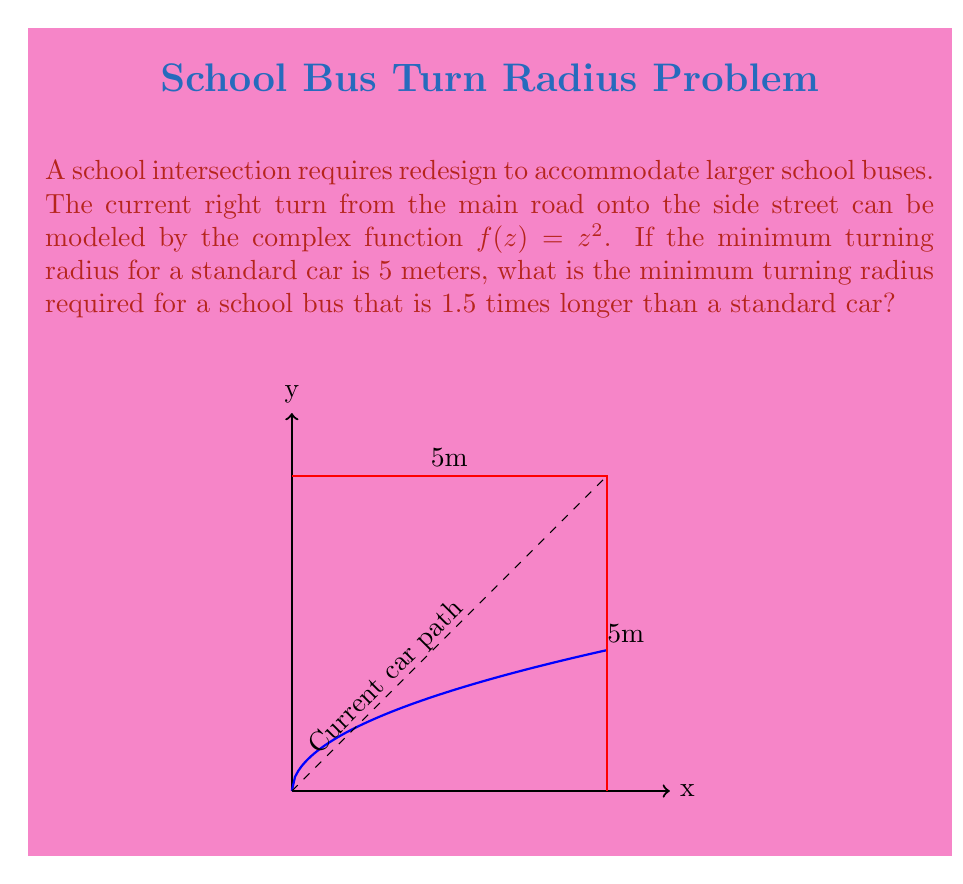Can you solve this math problem? Let's approach this step-by-step:

1) The complex function $f(z) = z^2$ maps the quarter circle in the first quadrant to the positive real axis. This represents the turning path of the vehicle.

2) For a standard car with a turning radius of 5 meters, the domain of our function is a quarter circle with radius $\sqrt{5}$. This is because:

   $f(\sqrt{5}) = (\sqrt{5})^2 = 5$

3) The school bus is 1.5 times longer than a standard car. In the complex plane, this means we need to scale our input by a factor of 1.5.

4) Let's call the new radius for the school bus $r$. We want:

   $f(1.5\sqrt{5}) = (1.5\sqrt{5})^2 = r$

5) Expanding this:

   $(1.5\sqrt{5})^2 = 1.5^2 \cdot 5 = 2.25 \cdot 5 = 11.25$

6) Therefore, the minimum turning radius for the school bus is 11.25 meters.

This conformal mapping approach allows us to easily scale the turning radius while preserving the angles, which is crucial for designing intersections that can accommodate various vehicle sizes.
Answer: 11.25 meters 